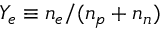<formula> <loc_0><loc_0><loc_500><loc_500>Y _ { e } \equiv n _ { e } / ( n _ { p } + n _ { n } )</formula> 